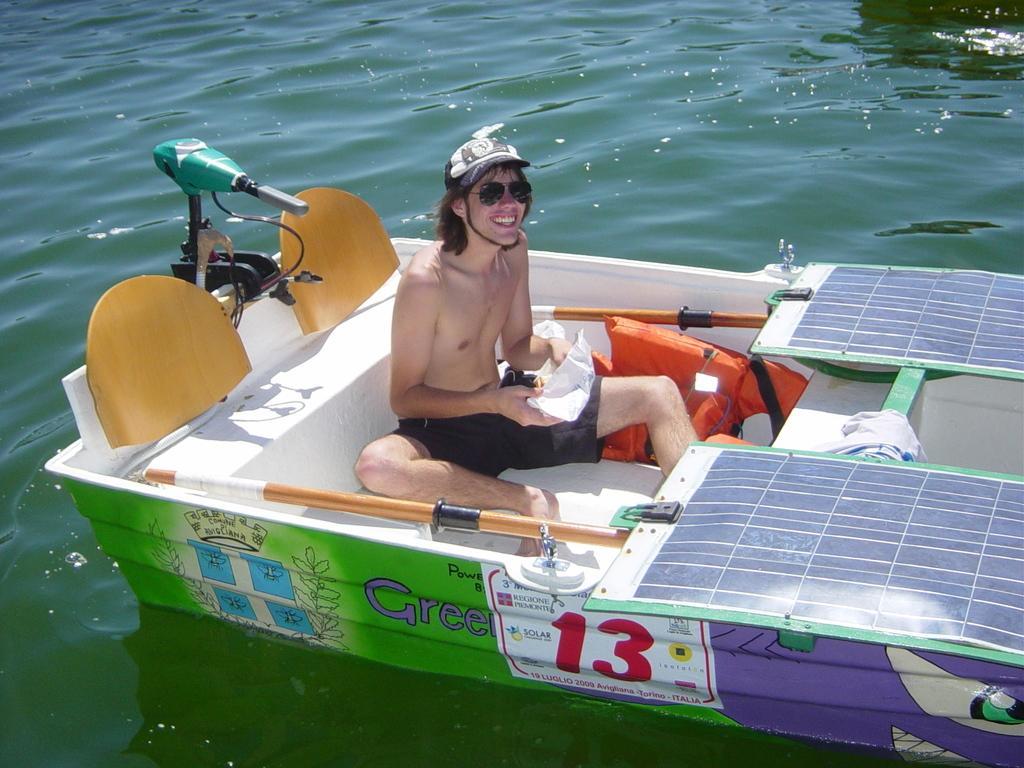Please provide a concise description of this image. This image is taken outdoors. At the bottom of the image there is a sea with water. In the middle of the image a man is sitting in the boat and he is holding a paper in his hands. He is with a smiling face. There are a few objects in the boat. 